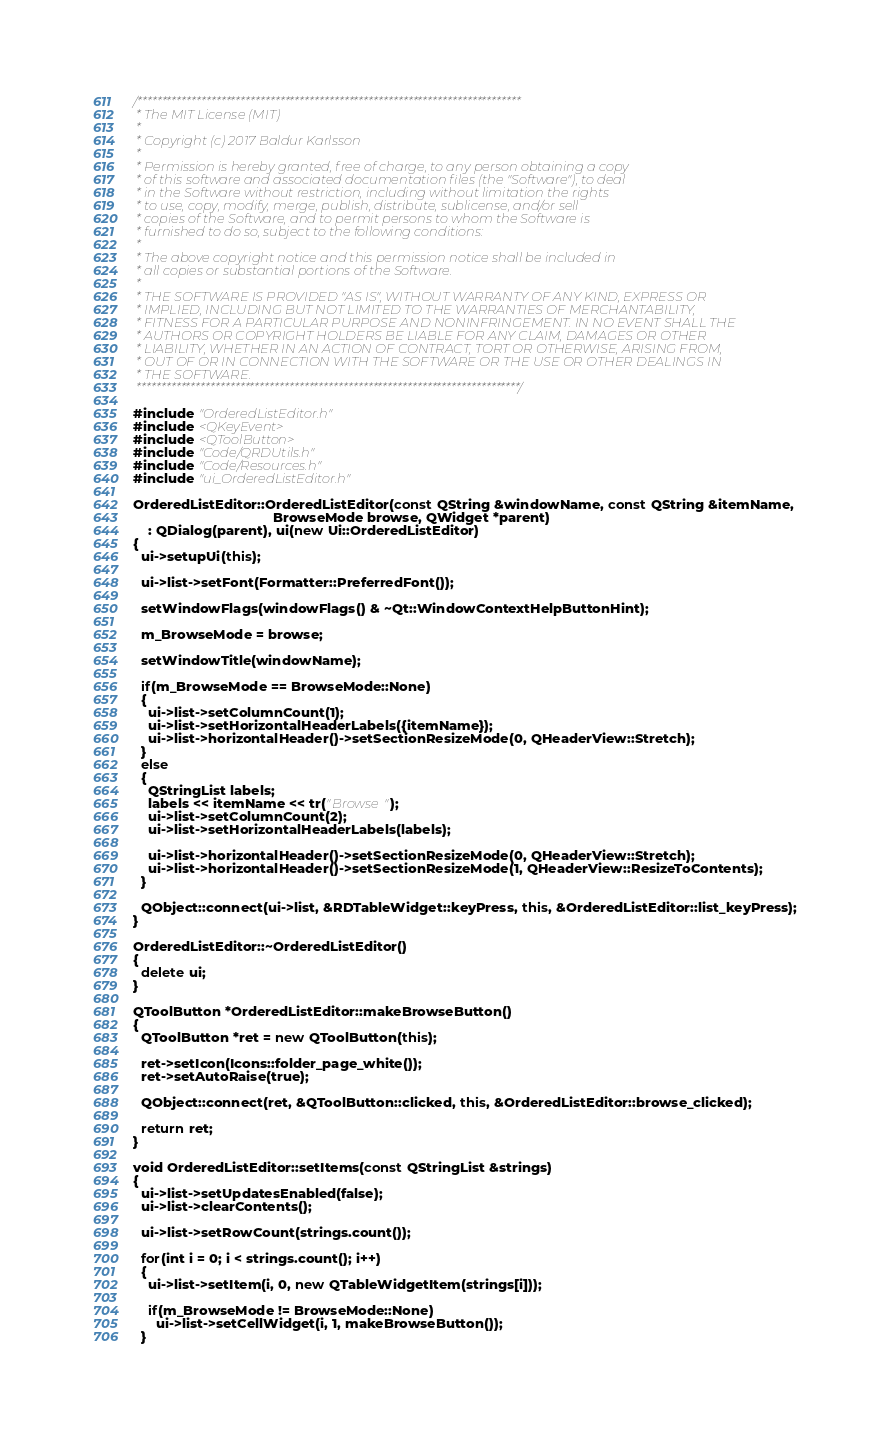Convert code to text. <code><loc_0><loc_0><loc_500><loc_500><_C++_>/******************************************************************************
 * The MIT License (MIT)
 *
 * Copyright (c) 2017 Baldur Karlsson
 *
 * Permission is hereby granted, free of charge, to any person obtaining a copy
 * of this software and associated documentation files (the "Software"), to deal
 * in the Software without restriction, including without limitation the rights
 * to use, copy, modify, merge, publish, distribute, sublicense, and/or sell
 * copies of the Software, and to permit persons to whom the Software is
 * furnished to do so, subject to the following conditions:
 *
 * The above copyright notice and this permission notice shall be included in
 * all copies or substantial portions of the Software.
 *
 * THE SOFTWARE IS PROVIDED "AS IS", WITHOUT WARRANTY OF ANY KIND, EXPRESS OR
 * IMPLIED, INCLUDING BUT NOT LIMITED TO THE WARRANTIES OF MERCHANTABILITY,
 * FITNESS FOR A PARTICULAR PURPOSE AND NONINFRINGEMENT. IN NO EVENT SHALL THE
 * AUTHORS OR COPYRIGHT HOLDERS BE LIABLE FOR ANY CLAIM, DAMAGES OR OTHER
 * LIABILITY, WHETHER IN AN ACTION OF CONTRACT, TORT OR OTHERWISE, ARISING FROM,
 * OUT OF OR IN CONNECTION WITH THE SOFTWARE OR THE USE OR OTHER DEALINGS IN
 * THE SOFTWARE.
 ******************************************************************************/

#include "OrderedListEditor.h"
#include <QKeyEvent>
#include <QToolButton>
#include "Code/QRDUtils.h"
#include "Code/Resources.h"
#include "ui_OrderedListEditor.h"

OrderedListEditor::OrderedListEditor(const QString &windowName, const QString &itemName,
                                     BrowseMode browse, QWidget *parent)
    : QDialog(parent), ui(new Ui::OrderedListEditor)
{
  ui->setupUi(this);

  ui->list->setFont(Formatter::PreferredFont());

  setWindowFlags(windowFlags() & ~Qt::WindowContextHelpButtonHint);

  m_BrowseMode = browse;

  setWindowTitle(windowName);

  if(m_BrowseMode == BrowseMode::None)
  {
    ui->list->setColumnCount(1);
    ui->list->setHorizontalHeaderLabels({itemName});
    ui->list->horizontalHeader()->setSectionResizeMode(0, QHeaderView::Stretch);
  }
  else
  {
    QStringList labels;
    labels << itemName << tr("Browse");
    ui->list->setColumnCount(2);
    ui->list->setHorizontalHeaderLabels(labels);

    ui->list->horizontalHeader()->setSectionResizeMode(0, QHeaderView::Stretch);
    ui->list->horizontalHeader()->setSectionResizeMode(1, QHeaderView::ResizeToContents);
  }

  QObject::connect(ui->list, &RDTableWidget::keyPress, this, &OrderedListEditor::list_keyPress);
}

OrderedListEditor::~OrderedListEditor()
{
  delete ui;
}

QToolButton *OrderedListEditor::makeBrowseButton()
{
  QToolButton *ret = new QToolButton(this);

  ret->setIcon(Icons::folder_page_white());
  ret->setAutoRaise(true);

  QObject::connect(ret, &QToolButton::clicked, this, &OrderedListEditor::browse_clicked);

  return ret;
}

void OrderedListEditor::setItems(const QStringList &strings)
{
  ui->list->setUpdatesEnabled(false);
  ui->list->clearContents();

  ui->list->setRowCount(strings.count());

  for(int i = 0; i < strings.count(); i++)
  {
    ui->list->setItem(i, 0, new QTableWidgetItem(strings[i]));

    if(m_BrowseMode != BrowseMode::None)
      ui->list->setCellWidget(i, 1, makeBrowseButton());
  }
</code> 